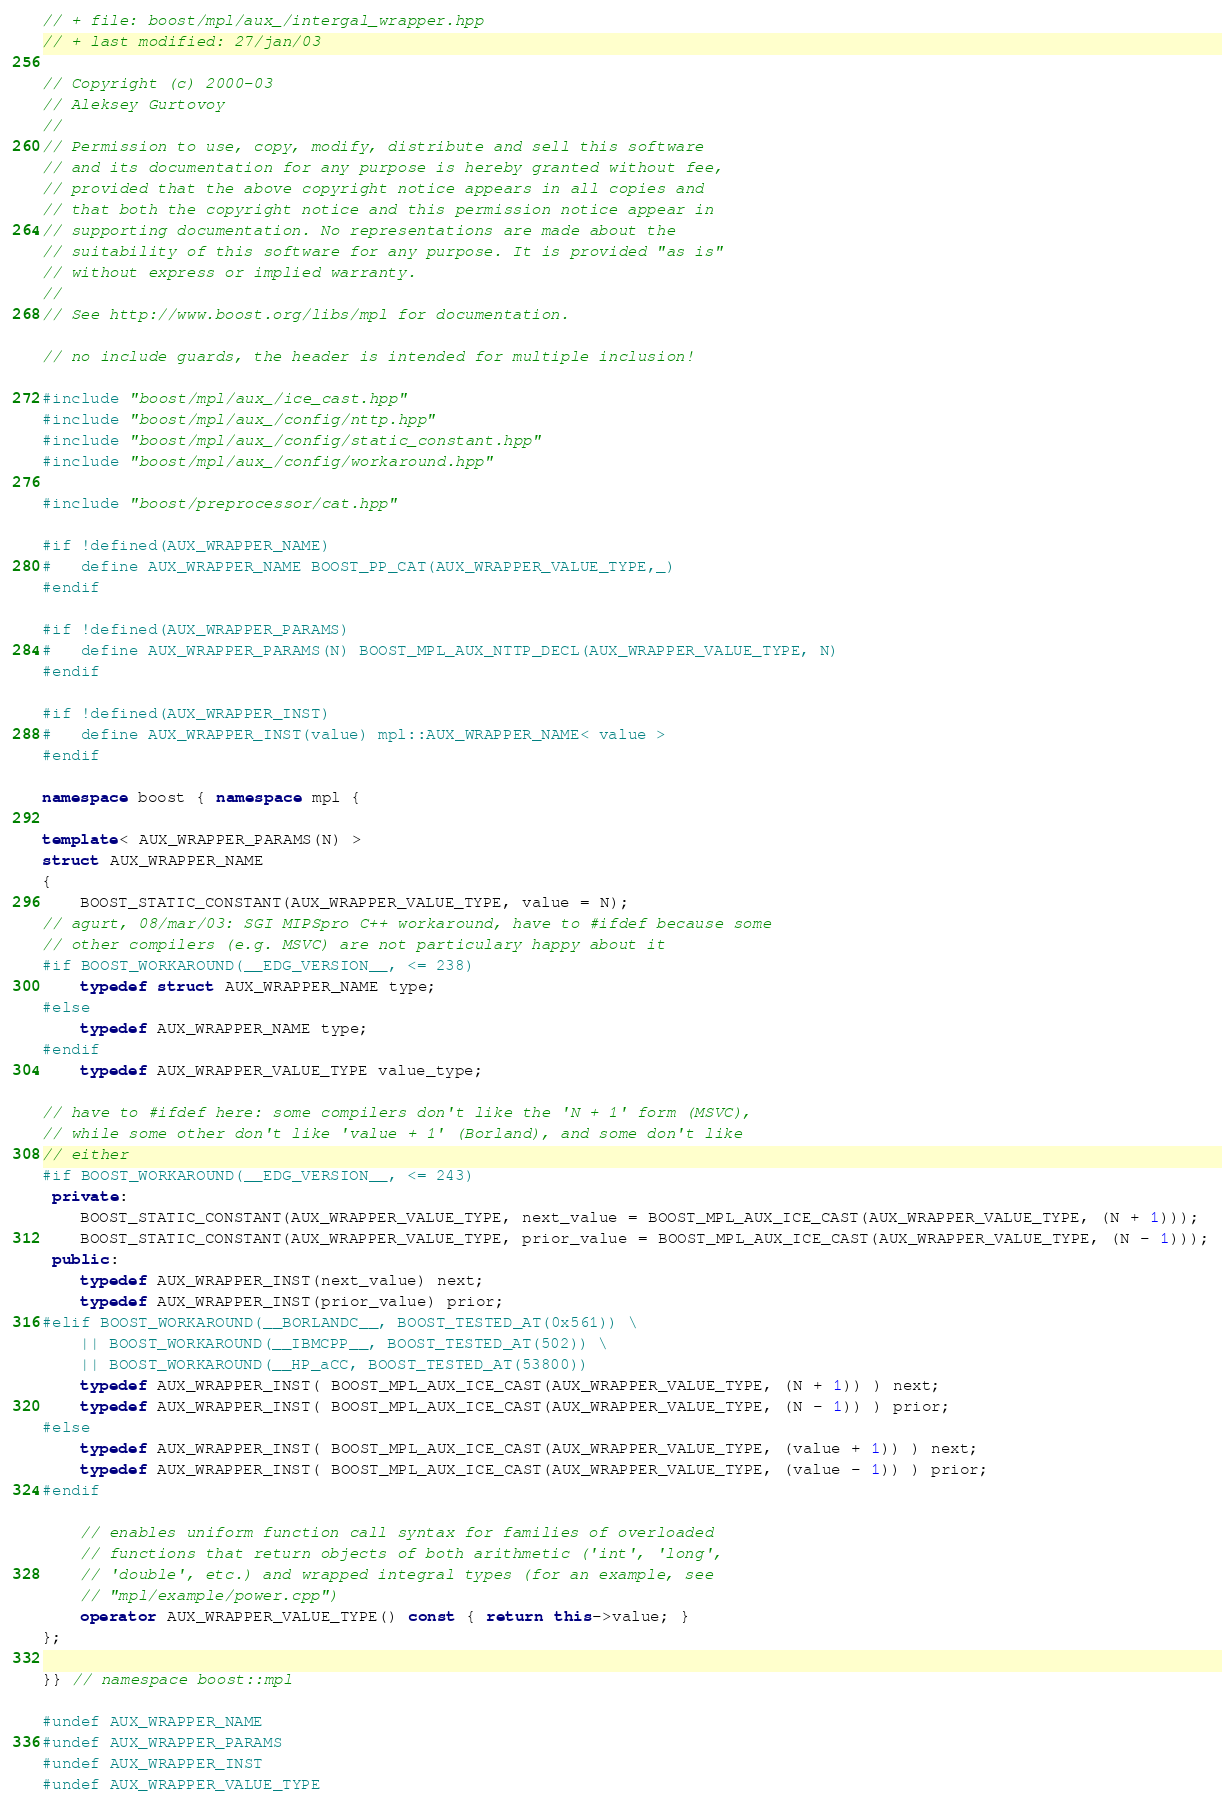<code> <loc_0><loc_0><loc_500><loc_500><_C++_>
// + file: boost/mpl/aux_/intergal_wrapper.hpp
// + last modified: 27/jan/03

// Copyright (c) 2000-03
// Aleksey Gurtovoy
//
// Permission to use, copy, modify, distribute and sell this software
// and its documentation for any purpose is hereby granted without fee, 
// provided that the above copyright notice appears in all copies and 
// that both the copyright notice and this permission notice appear in 
// supporting documentation. No representations are made about the 
// suitability of this software for any purpose. It is provided "as is" 
// without express or implied warranty.
//
// See http://www.boost.org/libs/mpl for documentation.

// no include guards, the header is intended for multiple inclusion!

#include "boost/mpl/aux_/ice_cast.hpp"
#include "boost/mpl/aux_/config/nttp.hpp"
#include "boost/mpl/aux_/config/static_constant.hpp"
#include "boost/mpl/aux_/config/workaround.hpp"

#include "boost/preprocessor/cat.hpp"

#if !defined(AUX_WRAPPER_NAME)
#   define AUX_WRAPPER_NAME BOOST_PP_CAT(AUX_WRAPPER_VALUE_TYPE,_)
#endif

#if !defined(AUX_WRAPPER_PARAMS)
#   define AUX_WRAPPER_PARAMS(N) BOOST_MPL_AUX_NTTP_DECL(AUX_WRAPPER_VALUE_TYPE, N)
#endif

#if !defined(AUX_WRAPPER_INST)
#   define AUX_WRAPPER_INST(value) mpl::AUX_WRAPPER_NAME< value >
#endif

namespace boost { namespace mpl {

template< AUX_WRAPPER_PARAMS(N) >
struct AUX_WRAPPER_NAME
{
    BOOST_STATIC_CONSTANT(AUX_WRAPPER_VALUE_TYPE, value = N);
// agurt, 08/mar/03: SGI MIPSpro C++ workaround, have to #ifdef because some 
// other compilers (e.g. MSVC) are not particulary happy about it
#if BOOST_WORKAROUND(__EDG_VERSION__, <= 238)
    typedef struct AUX_WRAPPER_NAME type;
#else
    typedef AUX_WRAPPER_NAME type;
#endif
    typedef AUX_WRAPPER_VALUE_TYPE value_type;

// have to #ifdef here: some compilers don't like the 'N + 1' form (MSVC),
// while some other don't like 'value + 1' (Borland), and some don't like
// either
#if BOOST_WORKAROUND(__EDG_VERSION__, <= 243)
 private:
    BOOST_STATIC_CONSTANT(AUX_WRAPPER_VALUE_TYPE, next_value = BOOST_MPL_AUX_ICE_CAST(AUX_WRAPPER_VALUE_TYPE, (N + 1)));
    BOOST_STATIC_CONSTANT(AUX_WRAPPER_VALUE_TYPE, prior_value = BOOST_MPL_AUX_ICE_CAST(AUX_WRAPPER_VALUE_TYPE, (N - 1)));
 public:
    typedef AUX_WRAPPER_INST(next_value) next;
    typedef AUX_WRAPPER_INST(prior_value) prior;
#elif BOOST_WORKAROUND(__BORLANDC__, BOOST_TESTED_AT(0x561)) \
    || BOOST_WORKAROUND(__IBMCPP__, BOOST_TESTED_AT(502)) \
    || BOOST_WORKAROUND(__HP_aCC, BOOST_TESTED_AT(53800))
    typedef AUX_WRAPPER_INST( BOOST_MPL_AUX_ICE_CAST(AUX_WRAPPER_VALUE_TYPE, (N + 1)) ) next;
    typedef AUX_WRAPPER_INST( BOOST_MPL_AUX_ICE_CAST(AUX_WRAPPER_VALUE_TYPE, (N - 1)) ) prior;
#else
    typedef AUX_WRAPPER_INST( BOOST_MPL_AUX_ICE_CAST(AUX_WRAPPER_VALUE_TYPE, (value + 1)) ) next;
    typedef AUX_WRAPPER_INST( BOOST_MPL_AUX_ICE_CAST(AUX_WRAPPER_VALUE_TYPE, (value - 1)) ) prior;
#endif

    // enables uniform function call syntax for families of overloaded 
    // functions that return objects of both arithmetic ('int', 'long',
    // 'double', etc.) and wrapped integral types (for an example, see 
    // "mpl/example/power.cpp")
    operator AUX_WRAPPER_VALUE_TYPE() const { return this->value; } 
};

}} // namespace boost::mpl

#undef AUX_WRAPPER_NAME
#undef AUX_WRAPPER_PARAMS
#undef AUX_WRAPPER_INST
#undef AUX_WRAPPER_VALUE_TYPE
</code> 